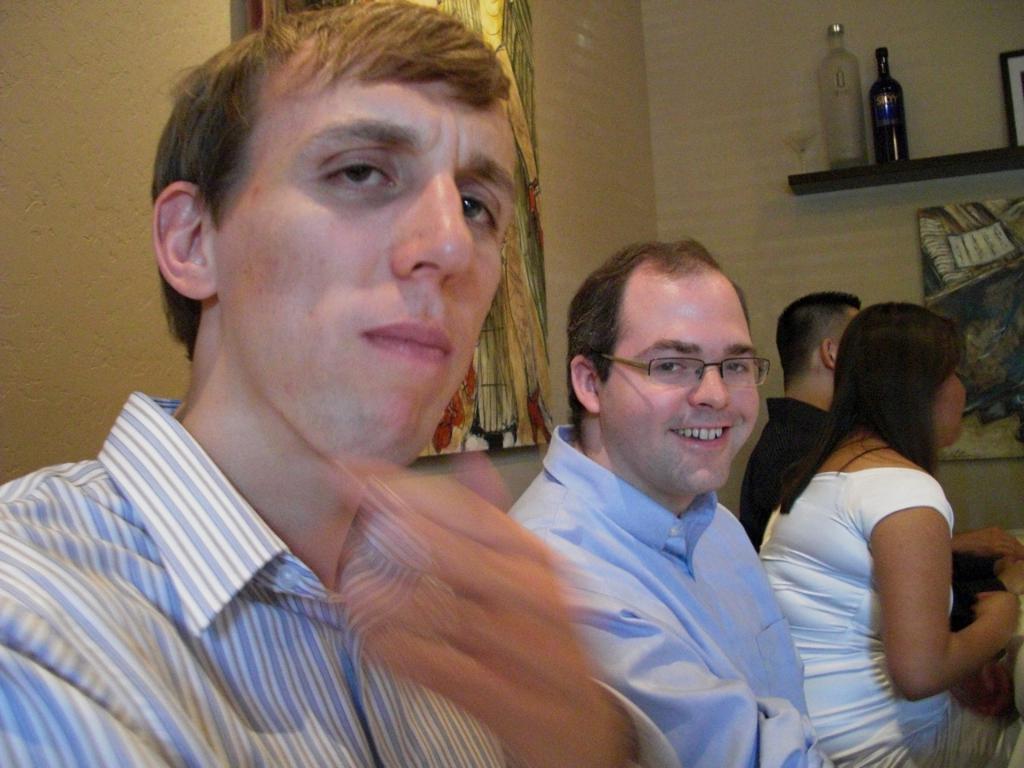In one or two sentences, can you explain what this image depicts? In this picture we can see there are four persons sitting. Behind the people, there is an object on the wall. At the top right corner of the image, there are bottles and an object on the wooden surface. 